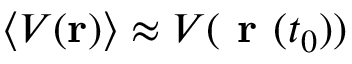Convert formula to latex. <formula><loc_0><loc_0><loc_500><loc_500>\langle V ( r ) \rangle \approx V ( r ( t _ { 0 } ) )</formula> 